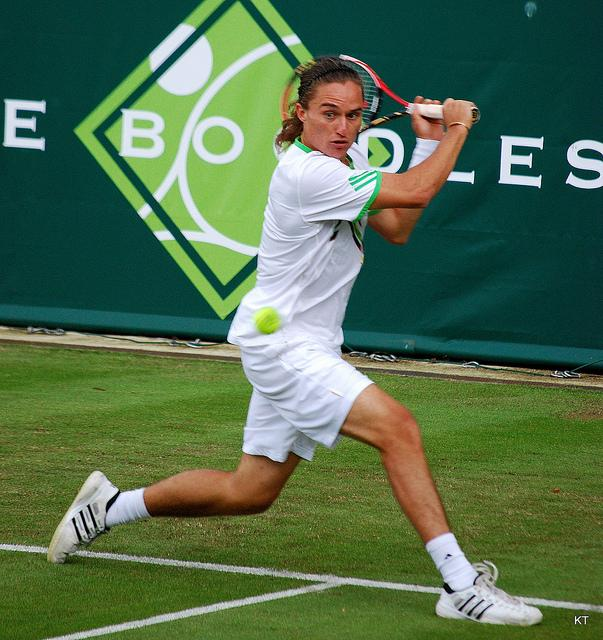What is the color of tennis ball used in earlier days? green 